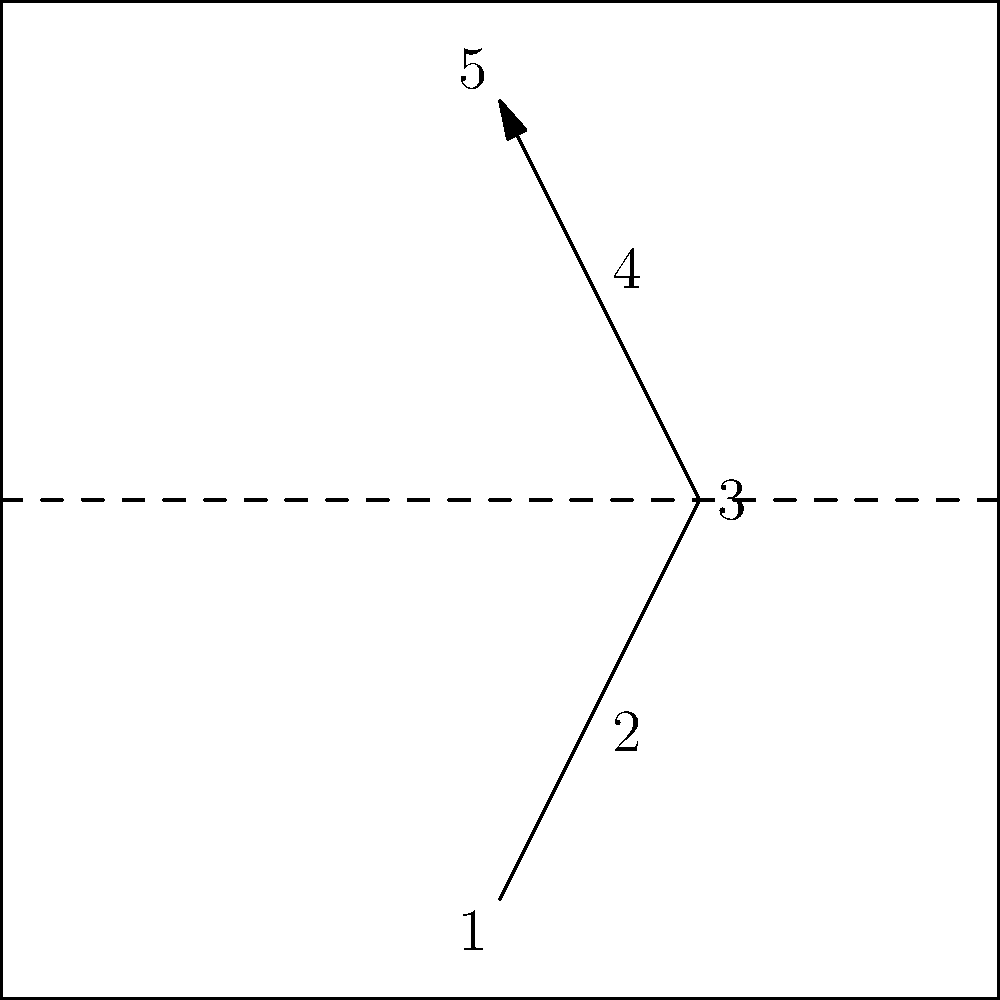Based on the arrow diagram representing footwork on a badminton court, which advanced defensive move is this pattern most likely associated with? Let's analyze the footwork pattern step-by-step:

1. The pattern starts near the back center of the court.
2. It moves diagonally forward to the right.
3. The third step is directly to the side, near the net.
4. The fourth step moves diagonally back to the left.
5. The final step returns to the back center of the court.

This footwork pattern is characteristic of a defensive move known as the "around-the-head clear." This move is used when a right-handed player needs to return a shot that's coming to their backhand side (left side for right-handed players).

The player:
1. Starts in a ready position at the back of the court.
2. Moves diagonally forward to get behind the incoming shuttle.
3. Steps to the side to create space for the racket swing.
4. Moves the racket around their head to hit the shuttle.
5. Recovers back to the center of the court.

This advanced move allows players to return difficult shots from their backhand side using a forehand stroke, providing more power and control.
Answer: Around-the-head clear 